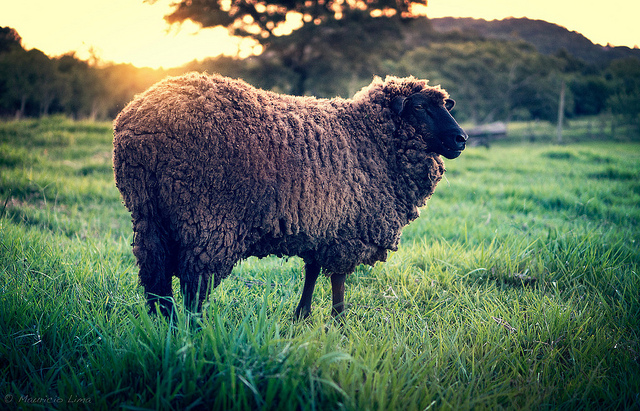Is there any water body, like a river or pond, in the image? No, there isn't any visible water body like a river or pond in the image. The focus is primarily on the sheep and the expansive grassy field surrounding it. 